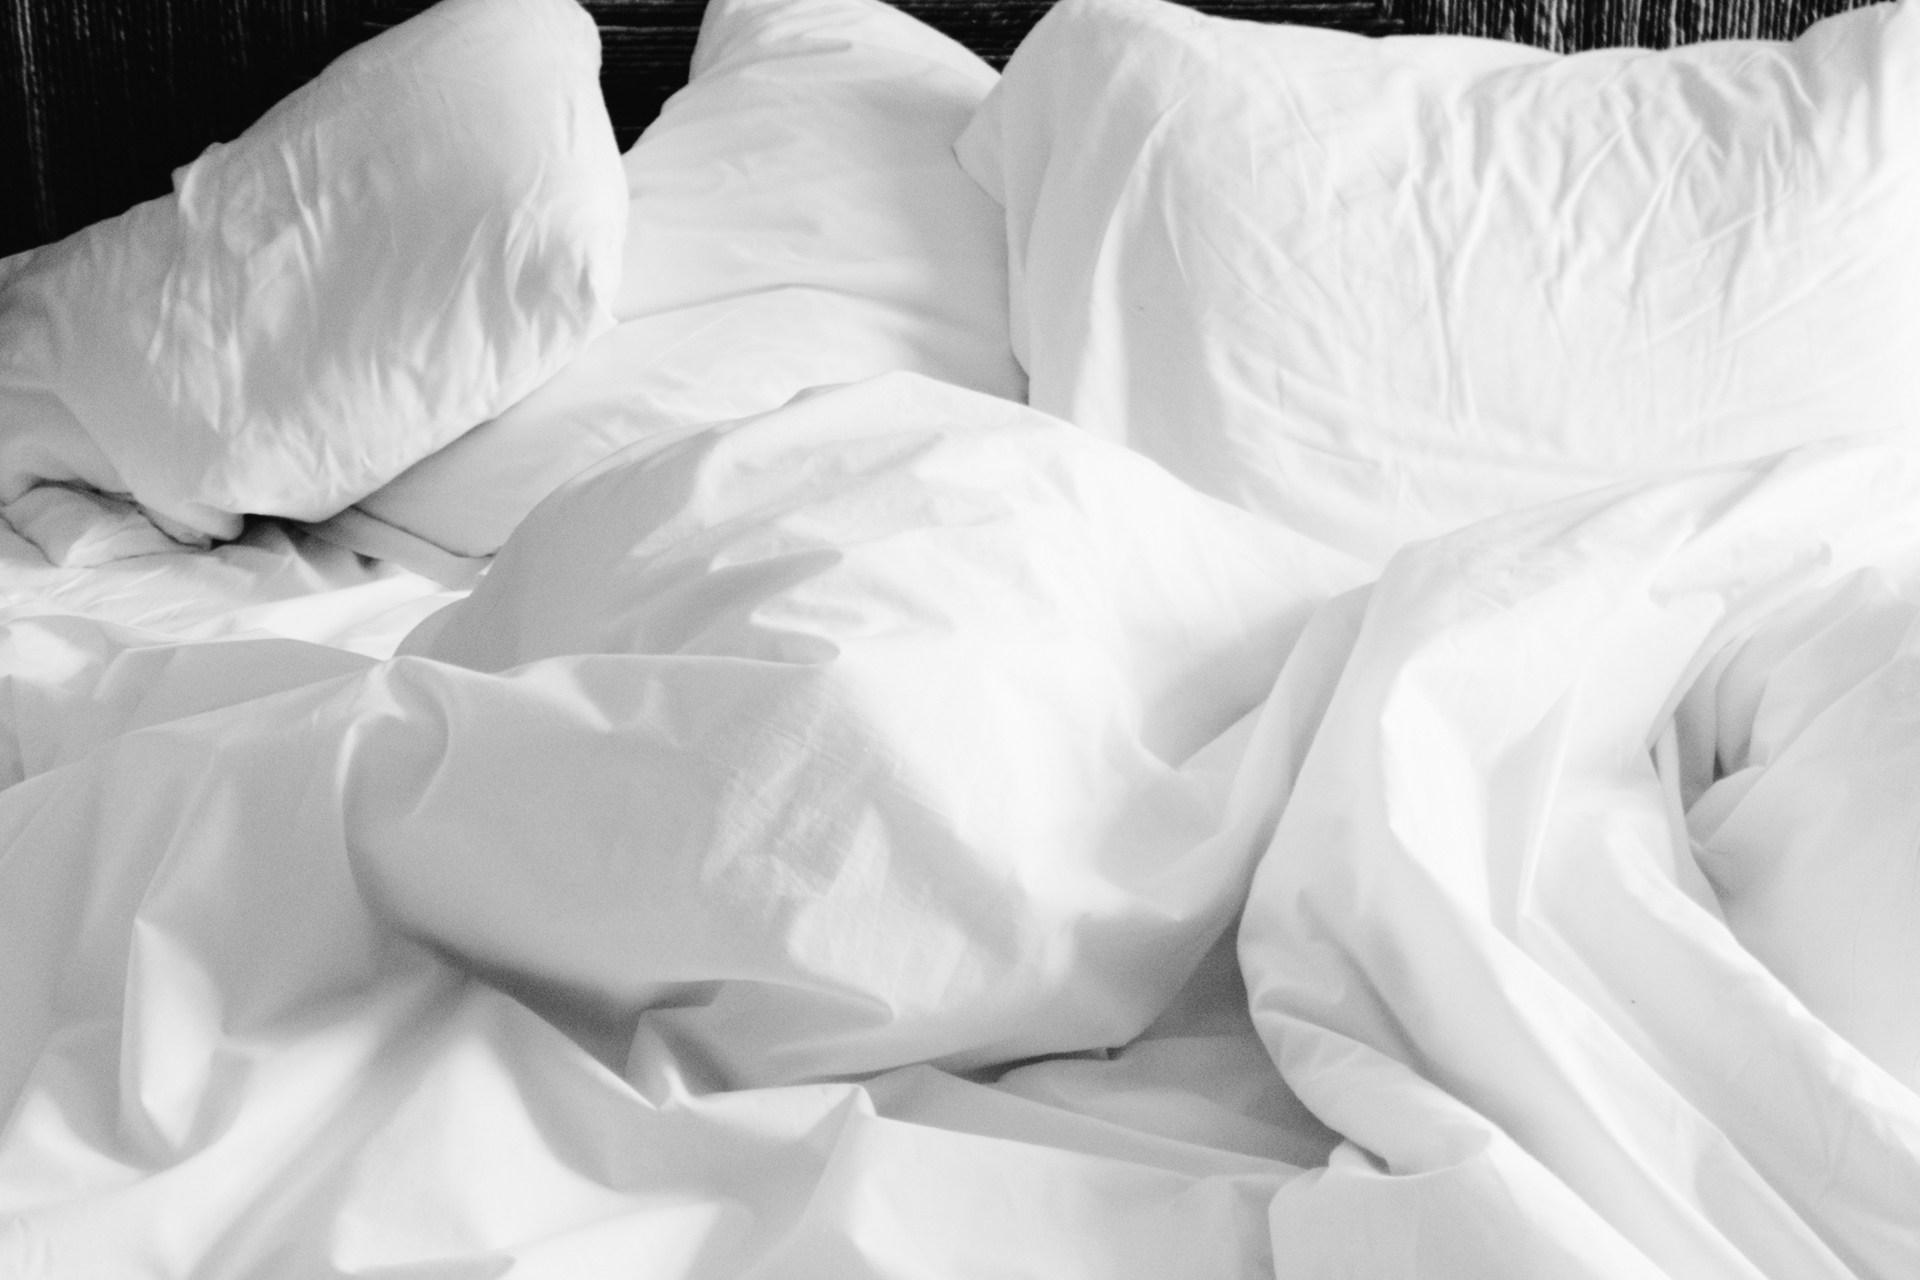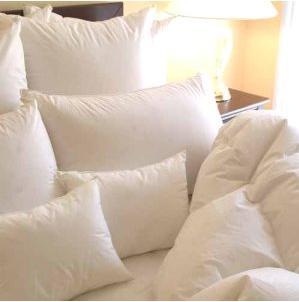The first image is the image on the left, the second image is the image on the right. Analyze the images presented: Is the assertion "One of the images contains exactly two white pillows." valid? Answer yes or no. No. 